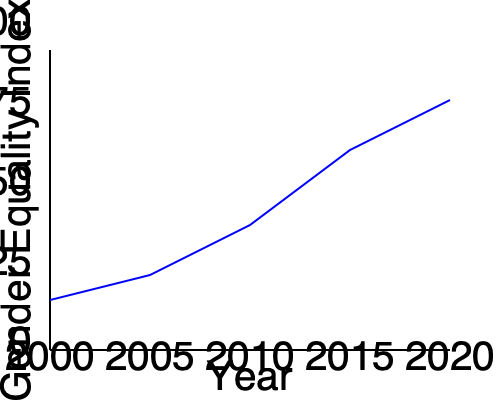Based on the line graph showing the Gender Equality Index from 2000 to 2020, what can be concluded about the progress of gender equality over this period? To answer this question, let's analyze the graph step-by-step:

1. The x-axis represents years from 2000 to 2020 in 5-year intervals.
2. The y-axis represents the Gender Equality Index from 0 to 100.
3. The blue line represents the trend of the Gender Equality Index over time.

Observing the line:
1. In 2000, the index starts at a relatively low point, around 20-25.
2. By 2005, there's a slight increase, with the index rising to about 30.
3. In 2010, we see a more significant jump, with the index reaching around 45.
4. The steepest increase occurs between 2010 and 2015, with the index rising to about 65.
5. From 2015 to 2020, the upward trend continues, with the index reaching approximately 80.

Key observations:
1. The line shows a consistent upward trend throughout the entire period.
2. The rate of increase accelerates over time, with the steepest rise occurring in the latter half of the period.
3. There are no periods of decline or stagnation in the index.

Given these observations, we can conclude that there has been steady and accelerating progress in gender equality from 2000 to 2020, as measured by this index.
Answer: Steady and accelerating progress in gender equality from 2000 to 2020. 